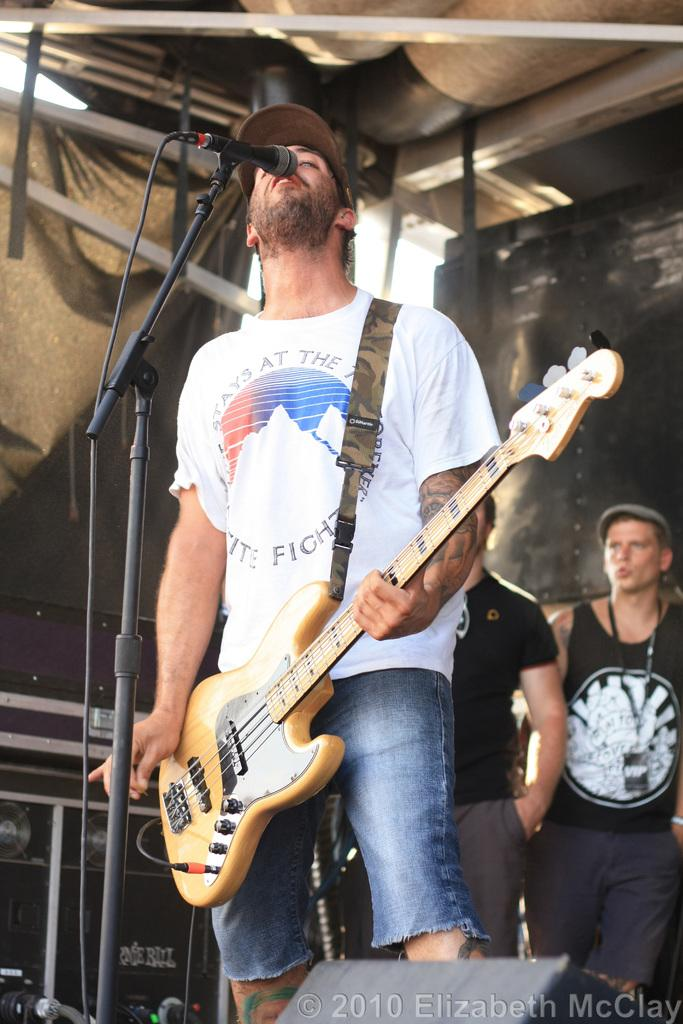What is the man in the image doing? The man is standing, holding a guitar, and singing into a microphone. What is the man wearing on his head? The man is wearing a cap. How many other people are in the image? There are two other people in the image. What are the two people doing? The two people are standing and looking at the man. What is the rate of planes flying over the man in the image? There is no mention of planes in the image, so it is not possible to determine their rate of flight. 